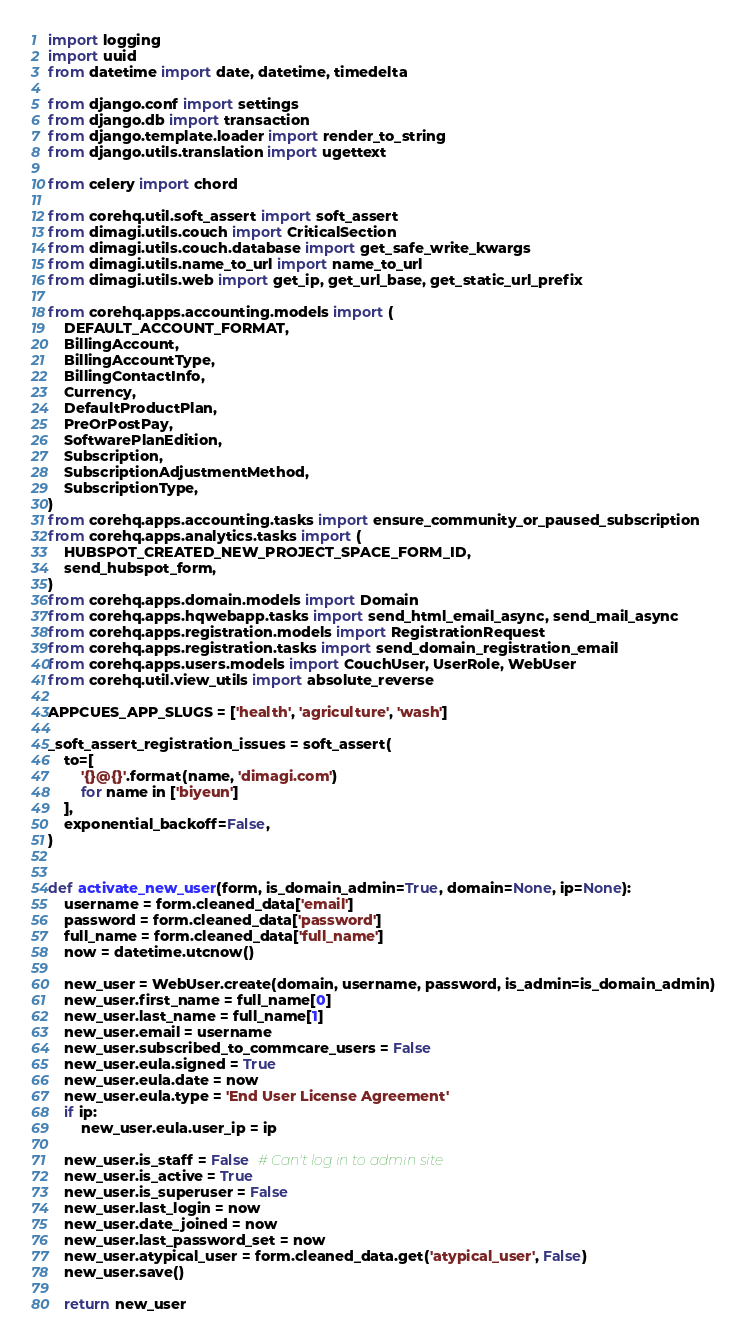Convert code to text. <code><loc_0><loc_0><loc_500><loc_500><_Python_>import logging
import uuid
from datetime import date, datetime, timedelta

from django.conf import settings
from django.db import transaction
from django.template.loader import render_to_string
from django.utils.translation import ugettext

from celery import chord

from corehq.util.soft_assert import soft_assert
from dimagi.utils.couch import CriticalSection
from dimagi.utils.couch.database import get_safe_write_kwargs
from dimagi.utils.name_to_url import name_to_url
from dimagi.utils.web import get_ip, get_url_base, get_static_url_prefix

from corehq.apps.accounting.models import (
    DEFAULT_ACCOUNT_FORMAT,
    BillingAccount,
    BillingAccountType,
    BillingContactInfo,
    Currency,
    DefaultProductPlan,
    PreOrPostPay,
    SoftwarePlanEdition,
    Subscription,
    SubscriptionAdjustmentMethod,
    SubscriptionType,
)
from corehq.apps.accounting.tasks import ensure_community_or_paused_subscription
from corehq.apps.analytics.tasks import (
    HUBSPOT_CREATED_NEW_PROJECT_SPACE_FORM_ID,
    send_hubspot_form,
)
from corehq.apps.domain.models import Domain
from corehq.apps.hqwebapp.tasks import send_html_email_async, send_mail_async
from corehq.apps.registration.models import RegistrationRequest
from corehq.apps.registration.tasks import send_domain_registration_email
from corehq.apps.users.models import CouchUser, UserRole, WebUser
from corehq.util.view_utils import absolute_reverse

APPCUES_APP_SLUGS = ['health', 'agriculture', 'wash']

_soft_assert_registration_issues = soft_assert(
    to=[
        '{}@{}'.format(name, 'dimagi.com')
        for name in ['biyeun']
    ],
    exponential_backoff=False,
)


def activate_new_user(form, is_domain_admin=True, domain=None, ip=None):
    username = form.cleaned_data['email']
    password = form.cleaned_data['password']
    full_name = form.cleaned_data['full_name']
    now = datetime.utcnow()

    new_user = WebUser.create(domain, username, password, is_admin=is_domain_admin)
    new_user.first_name = full_name[0]
    new_user.last_name = full_name[1]
    new_user.email = username
    new_user.subscribed_to_commcare_users = False
    new_user.eula.signed = True
    new_user.eula.date = now
    new_user.eula.type = 'End User License Agreement'
    if ip:
        new_user.eula.user_ip = ip

    new_user.is_staff = False  # Can't log in to admin site
    new_user.is_active = True
    new_user.is_superuser = False
    new_user.last_login = now
    new_user.date_joined = now
    new_user.last_password_set = now
    new_user.atypical_user = form.cleaned_data.get('atypical_user', False)
    new_user.save()

    return new_user

</code> 